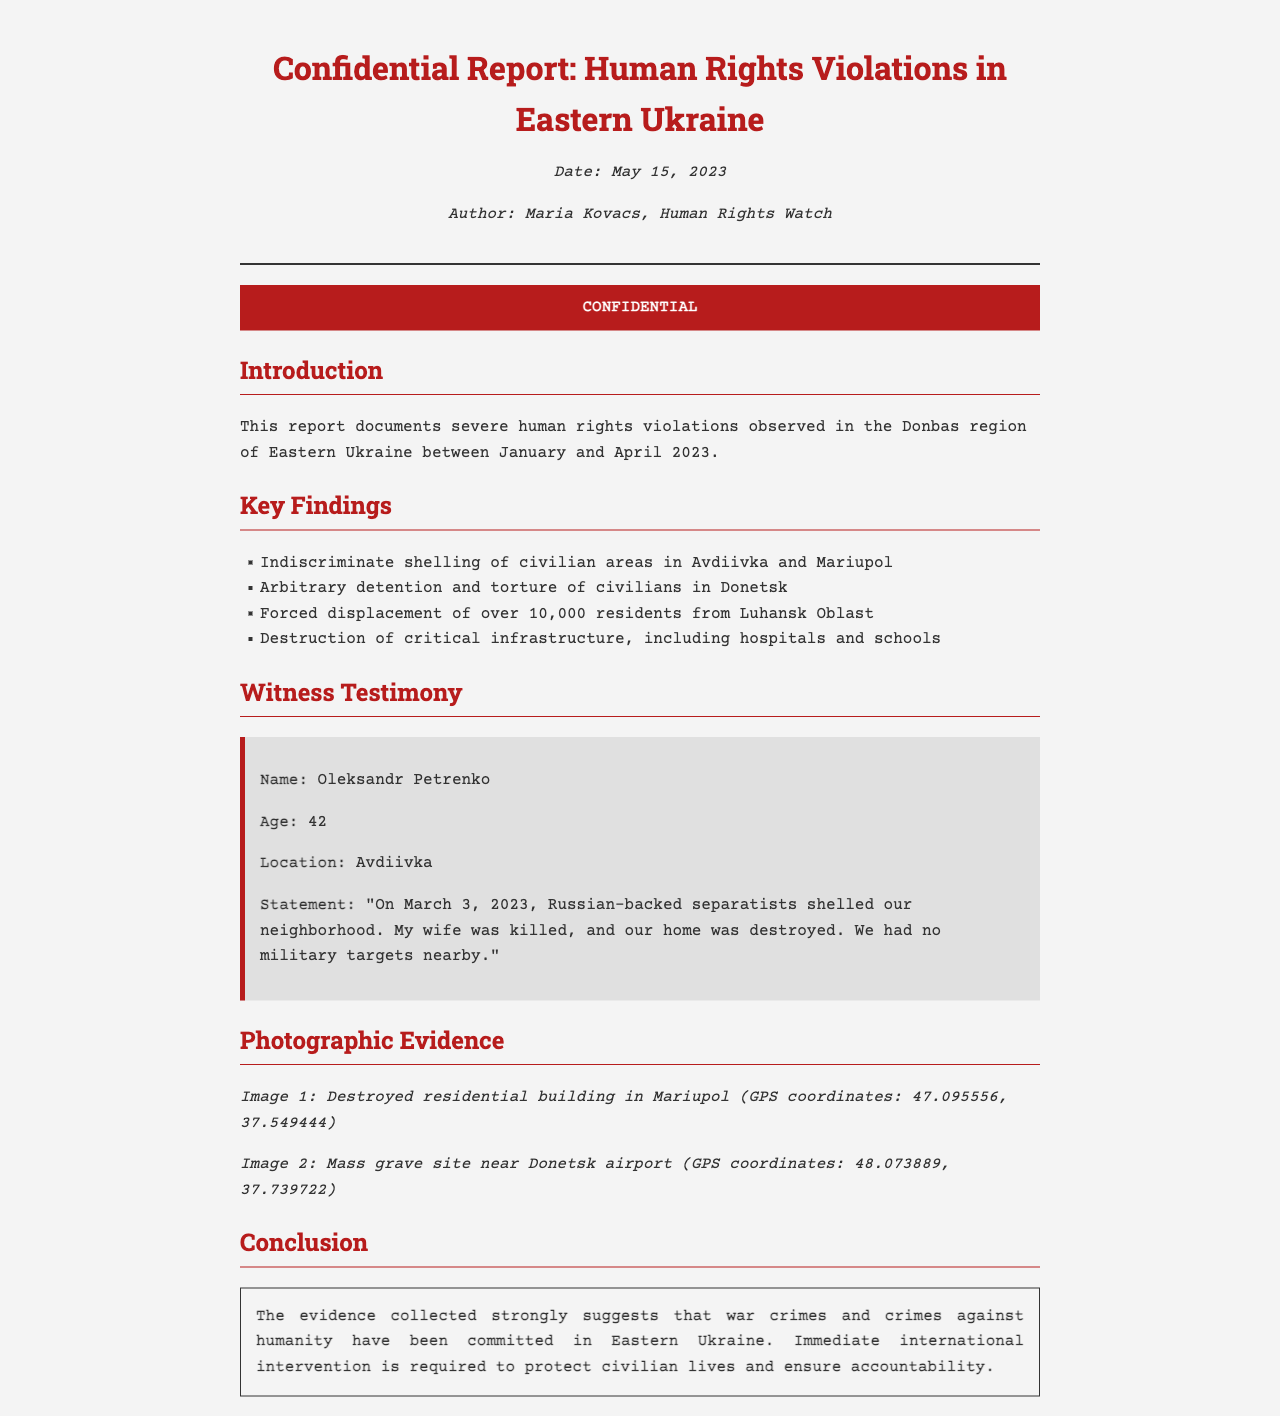What is the title of the report? The title is prominently displayed at the top of the document.
Answer: Confidential Report: Human Rights Violations in Eastern Ukraine Who authored the report? The author's name is listed towards the top under the date.
Answer: Maria Kovacs What was the date of the report? The date is mentioned in the fax meta section.
Answer: May 15, 2023 How many residents were forcibly displaced from Luhansk Oblast? This information is presented in the key findings section.
Answer: over 10,000 residents What was the age of the witness, Oleksandr Petrenko? The witness's age is stated in his testimony section.
Answer: 42 What was destroyed during the shelling mentioned by the witness? The witness's statement includes information about the consequence of the shelling.
Answer: his home What type of evidence is presented in the report? The section headings guide the type of evidence provided.
Answer: Photographic Evidence What recommendations does the report suggest? The conclusion outlines a critical recommendation.
Answer: international intervention Where is the destroyed residential building located? The coordinates in the photographic evidence section provide this information.
Answer: Mariupol What are the coordinates of the mass grave site? The coordinates listed offer specific location details.
Answer: 48.073889, 37.739722 